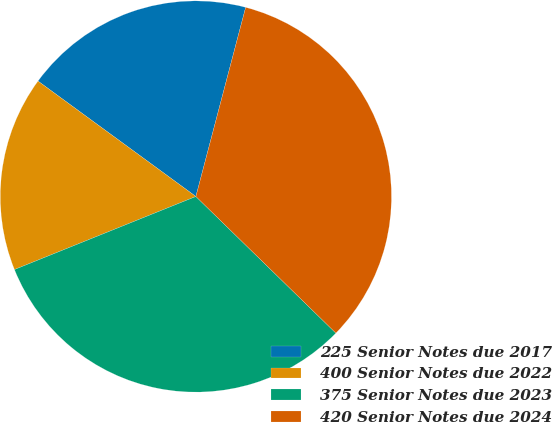<chart> <loc_0><loc_0><loc_500><loc_500><pie_chart><fcel>225 Senior Notes due 2017<fcel>400 Senior Notes due 2022<fcel>375 Senior Notes due 2023<fcel>420 Senior Notes due 2024<nl><fcel>19.05%<fcel>16.14%<fcel>31.6%<fcel>33.21%<nl></chart> 